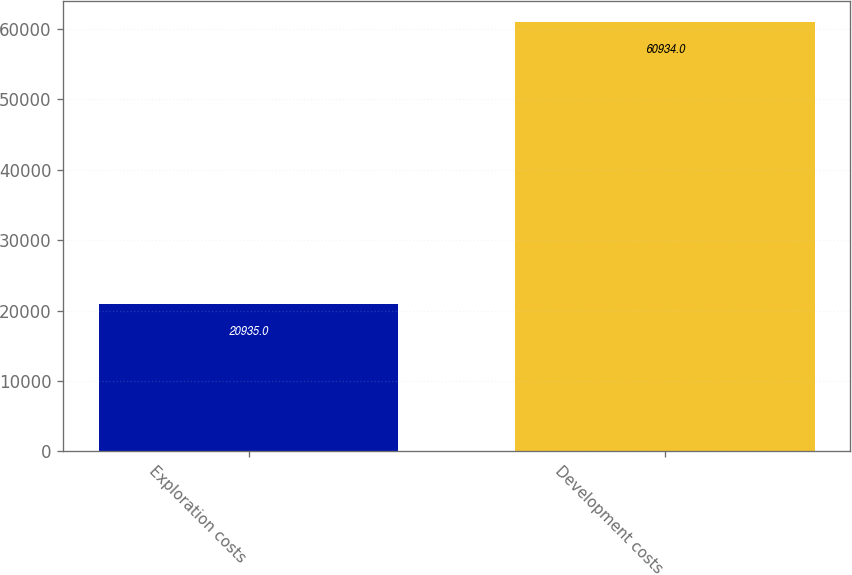<chart> <loc_0><loc_0><loc_500><loc_500><bar_chart><fcel>Exploration costs<fcel>Development costs<nl><fcel>20935<fcel>60934<nl></chart> 